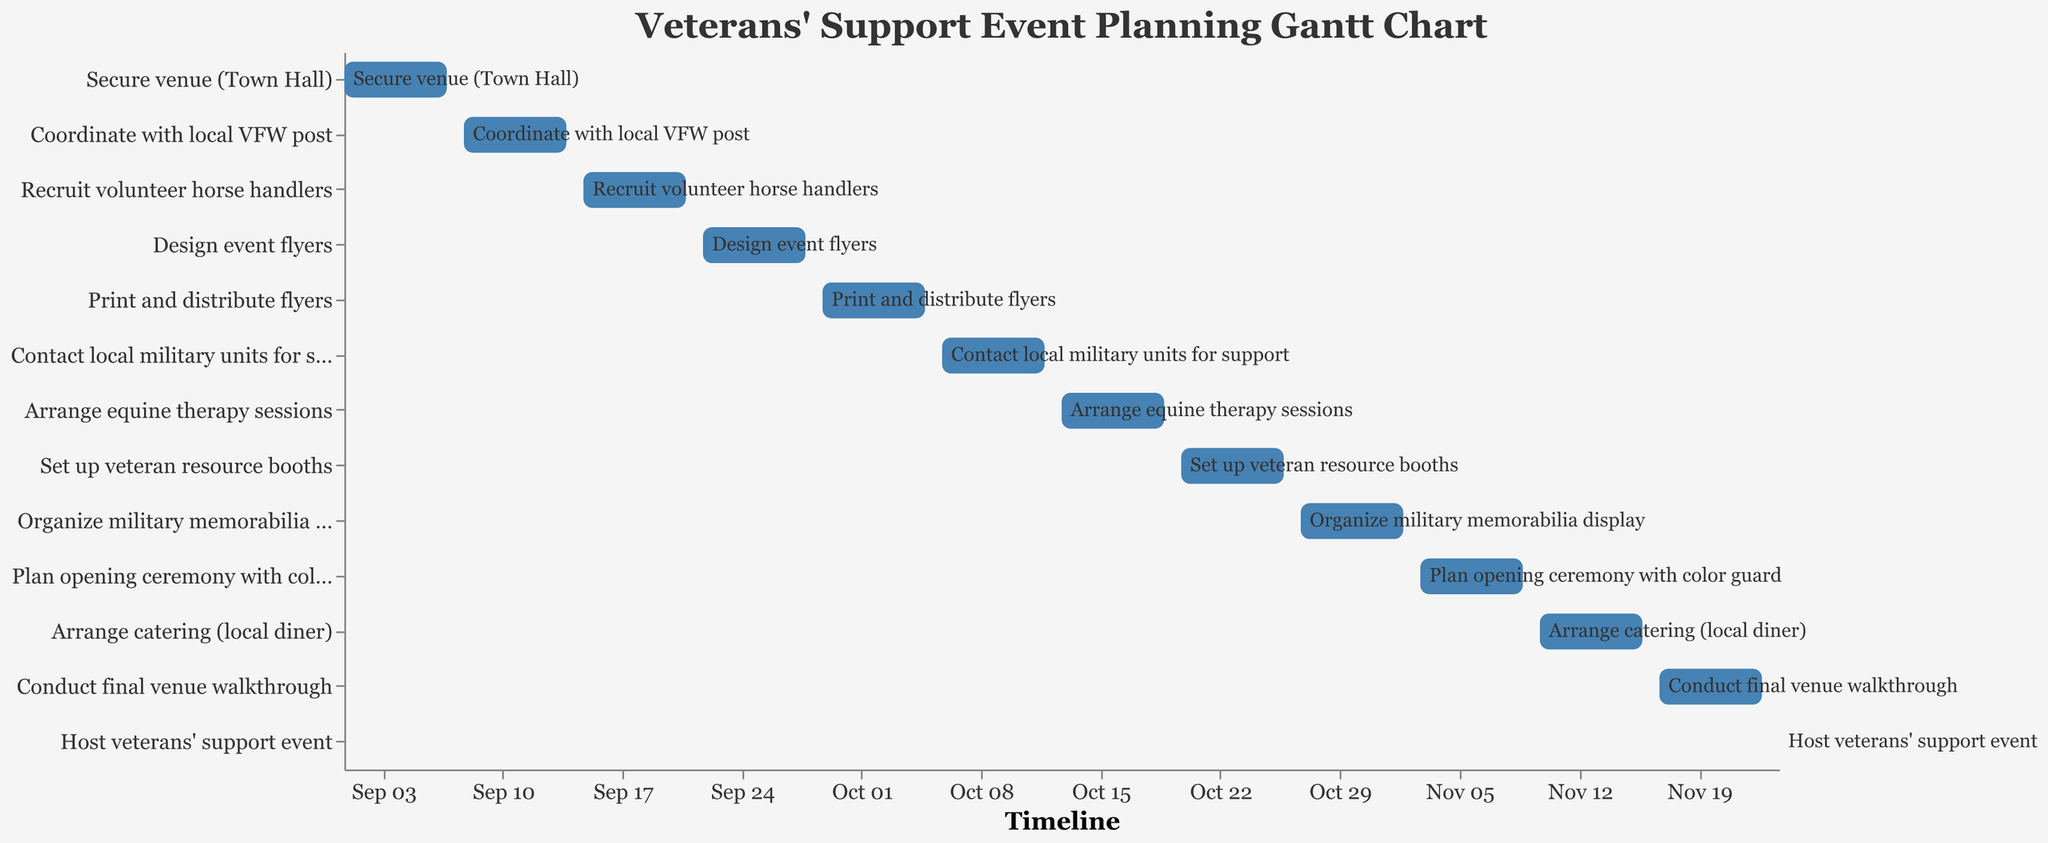How long does the "Secure venue (Town Hall)" task take? Find "Secure venue (Town Hall)" in the list of tasks and read the number of days in the duration column, which is 7 days.
Answer: 7 days What is the title of the Gantt Chart? Look at the top of the Gantt Chart to identify the title, which is "Veterans' Support Event Planning Gantt Chart".
Answer: Veterans' Support Event Planning Gantt Chart When does the "Print and distribute flyers" task start and end? Find the "Print and distribute flyers" task row and read the start and end dates, which are 2023-09-29 and 2023-10-05, respectively.
Answer: Starts: 2023-09-29, Ends: 2023-10-05 Which task takes the least amount of time? Identify the task with the shortest duration by checking the duration column; "Host veterans' support event" takes only 1 day.
Answer: Host veterans' support event Which tasks overlap completely with another task? Compare the start and end dates of tasks to identify any that overlap. None of the tasks in this schedule overlap completely.
Answer: None Which task needs to be completed first? Identify the task with the earliest start date, which is "Secure venue (Town Hall)" starting on 2023-09-01.
Answer: Secure venue (Town Hall) Which comes first: "Arrange equine therapy sessions" or "Coordinate with local VFW post"? Compare the start dates of both tasks. "Coordinate with local VFW post" starts on 2023-09-08, while "Arrange equine therapy sessions" starts on 2023-10-13, meaning the former comes first.
Answer: Coordinate with local VFW post How many tasks need to be completed before "Host veterans' support event"? Count all tasks with start dates before 2023-11-24. There are 12 tasks.
Answer: 12 tasks What is the total duration of all tasks combined? Sum up all durations from all tasks: 7 + 7 + 7 + 7 + 7 + 7 + 7 + 7 + 7 + 7 + 7 + 7 + 1 = 85 days.
Answer: 85 days When does the "Plan opening ceremony with color guard" task start? Find and read the start date for "Plan opening ceremony with color guard," which is 2023-11-03.
Answer: 2023-11-03 